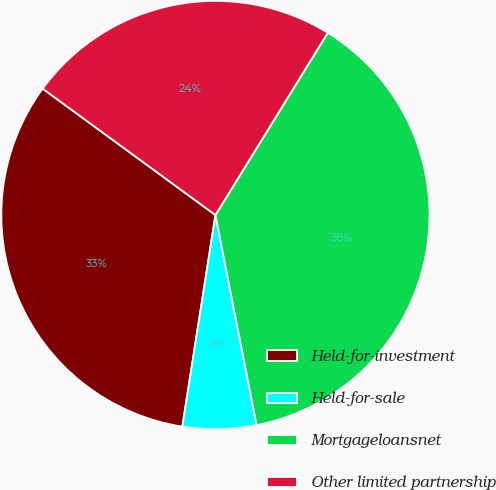Convert chart to OTSL. <chart><loc_0><loc_0><loc_500><loc_500><pie_chart><fcel>Held-for-investment<fcel>Held-for-sale<fcel>Mortgageloansnet<fcel>Other limited partnership<nl><fcel>32.58%<fcel>5.55%<fcel>38.13%<fcel>23.74%<nl></chart> 